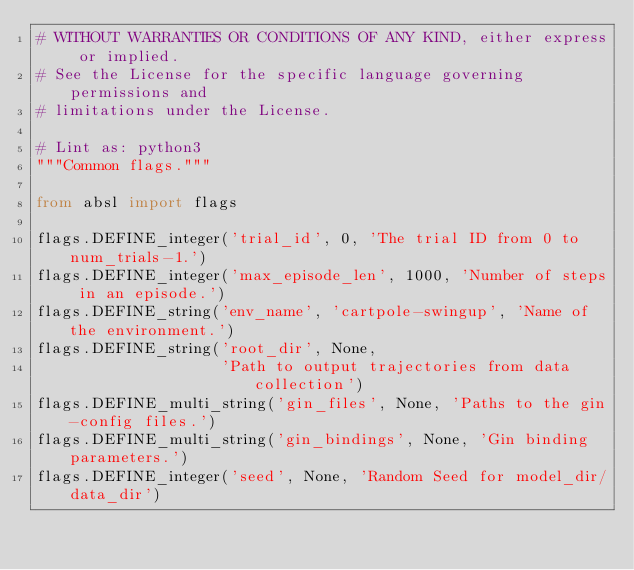<code> <loc_0><loc_0><loc_500><loc_500><_Python_># WITHOUT WARRANTIES OR CONDITIONS OF ANY KIND, either express or implied.
# See the License for the specific language governing permissions and
# limitations under the License.

# Lint as: python3
"""Common flags."""

from absl import flags

flags.DEFINE_integer('trial_id', 0, 'The trial ID from 0 to num_trials-1.')
flags.DEFINE_integer('max_episode_len', 1000, 'Number of steps in an episode.')
flags.DEFINE_string('env_name', 'cartpole-swingup', 'Name of the environment.')
flags.DEFINE_string('root_dir', None,
                    'Path to output trajectories from data collection')
flags.DEFINE_multi_string('gin_files', None, 'Paths to the gin-config files.')
flags.DEFINE_multi_string('gin_bindings', None, 'Gin binding parameters.')
flags.DEFINE_integer('seed', None, 'Random Seed for model_dir/data_dir')
</code> 